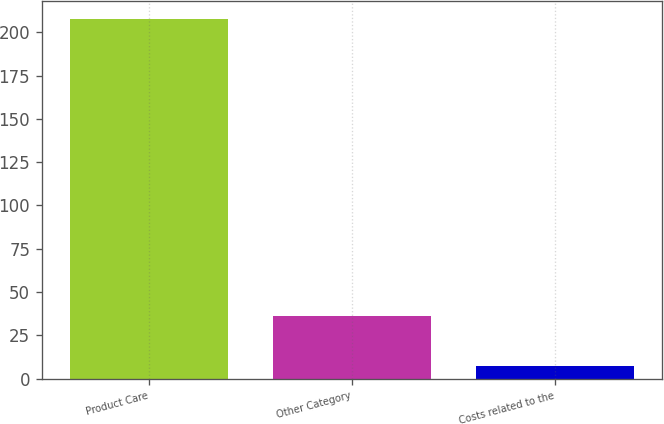Convert chart to OTSL. <chart><loc_0><loc_0><loc_500><loc_500><bar_chart><fcel>Product Care<fcel>Other Category<fcel>Costs related to the<nl><fcel>207.5<fcel>36<fcel>7.4<nl></chart> 